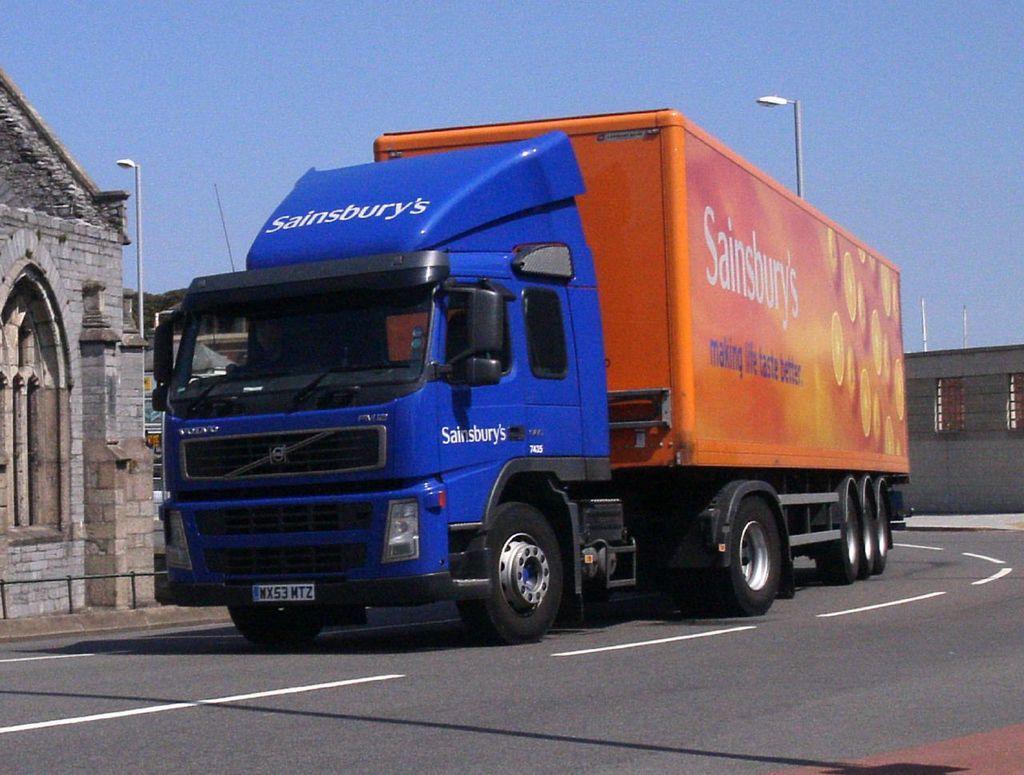Can you describe this image briefly? In this image there is the sky truncated towards the top of the image, there are poles, there are street lights, there is a wall truncated towards the right of the image, there is the road, there is a vehicle on the road, there is a building truncated towards the left of the image. 